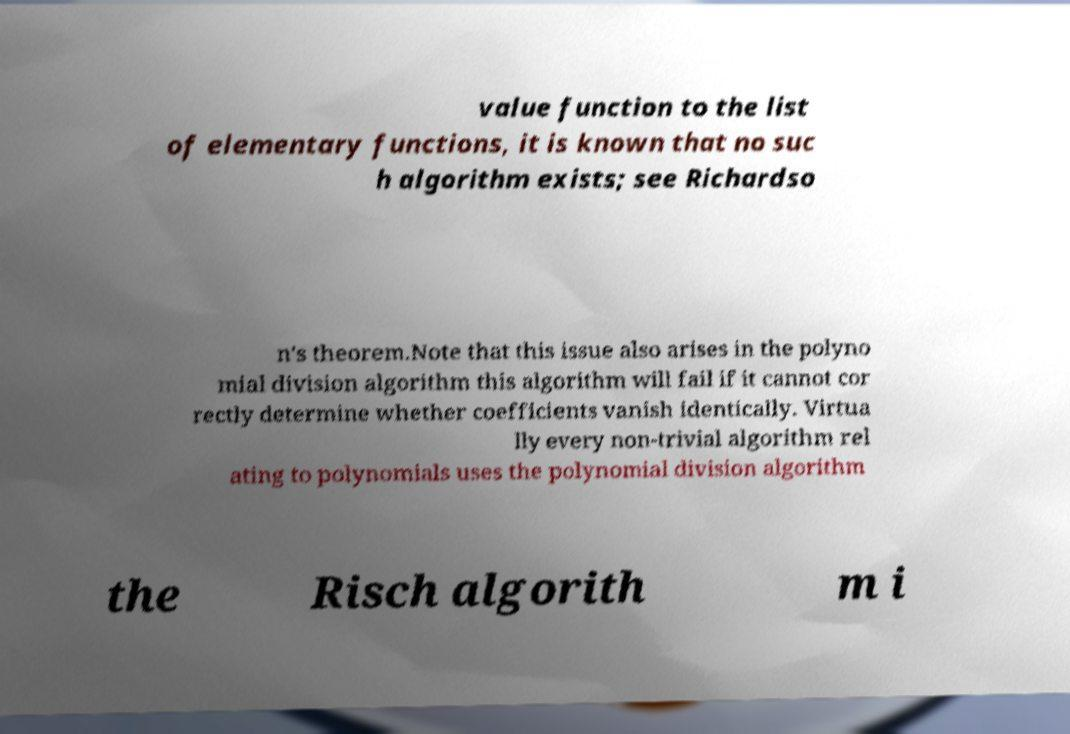For documentation purposes, I need the text within this image transcribed. Could you provide that? value function to the list of elementary functions, it is known that no suc h algorithm exists; see Richardso n's theorem.Note that this issue also arises in the polyno mial division algorithm this algorithm will fail if it cannot cor rectly determine whether coefficients vanish identically. Virtua lly every non-trivial algorithm rel ating to polynomials uses the polynomial division algorithm the Risch algorith m i 